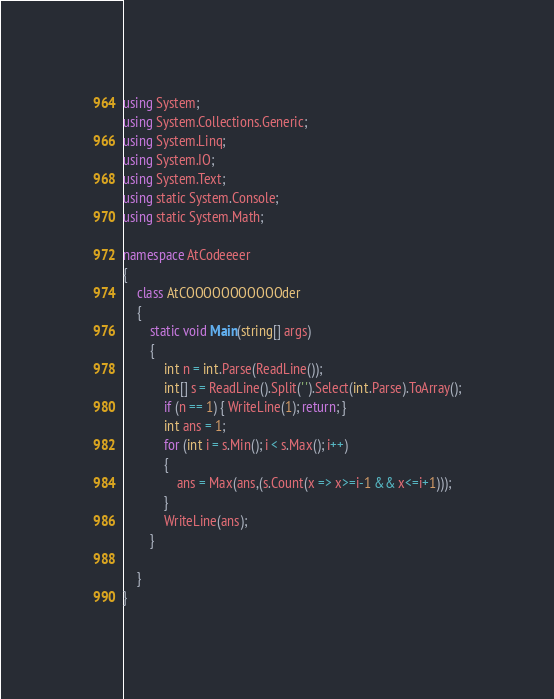Convert code to text. <code><loc_0><loc_0><loc_500><loc_500><_C#_>using System;
using System.Collections.Generic;
using System.Linq;
using System.IO;
using System.Text;
using static System.Console;
using static System.Math;

namespace AtCodeeeer
{
    class AtCOOOOOOOOOOOder
    {
        static void Main(string[] args)
        {
            int n = int.Parse(ReadLine());
            int[] s = ReadLine().Split(' ').Select(int.Parse).ToArray();
            if (n == 1) { WriteLine(1); return; }
            int ans = 1;
            for (int i = s.Min(); i < s.Max(); i++)
            {
                ans = Max(ans,(s.Count(x => x>=i-1 && x<=i+1)));
            }
            WriteLine(ans);
        }
        
    }
}</code> 